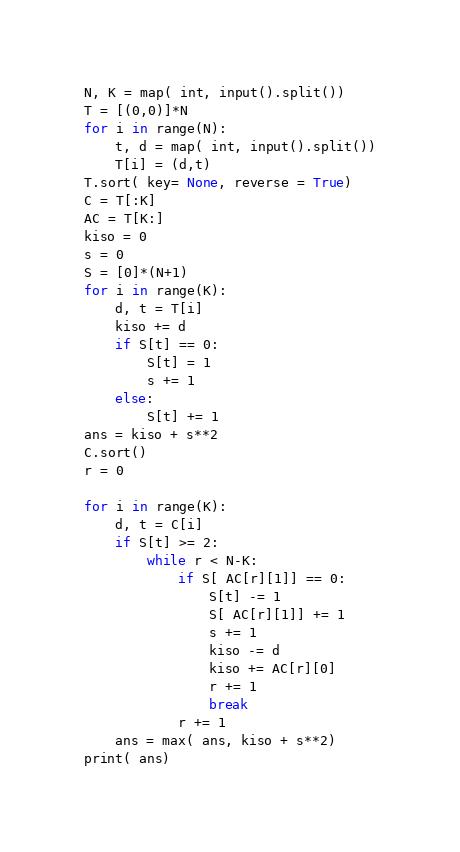<code> <loc_0><loc_0><loc_500><loc_500><_Python_>N, K = map( int, input().split())
T = [(0,0)]*N
for i in range(N):
    t, d = map( int, input().split())
    T[i] = (d,t)
T.sort( key= None, reverse = True)
C = T[:K]
AC = T[K:]
kiso = 0
s = 0
S = [0]*(N+1)
for i in range(K):
    d, t = T[i]
    kiso += d
    if S[t] == 0:
        S[t] = 1
        s += 1
    else:
        S[t] += 1
ans = kiso + s**2
C.sort()
r = 0

for i in range(K):
    d, t = C[i]
    if S[t] >= 2:
        while r < N-K:
            if S[ AC[r][1]] == 0:
                S[t] -= 1
                S[ AC[r][1]] += 1
                s += 1
                kiso -= d
                kiso += AC[r][0]
                r += 1
                break
            r += 1
    ans = max( ans, kiso + s**2)
print( ans)</code> 